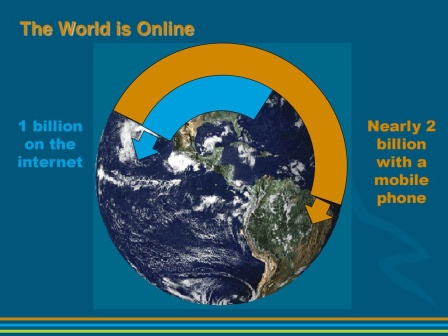How might the data represented in this image impact businesses in the digital age? The data depicted in this image suggests a massive audience online, which can profoundly influence business strategies. Businesses might see this as an opportunity to expand their digital footprint, invest heavily in online platforms, and tailor their marketing efforts to reach a broader, more tech-savvy audience. This can lead to more focused digital marketing strategies, e-commerce development, and customer engagement through digital channels. 